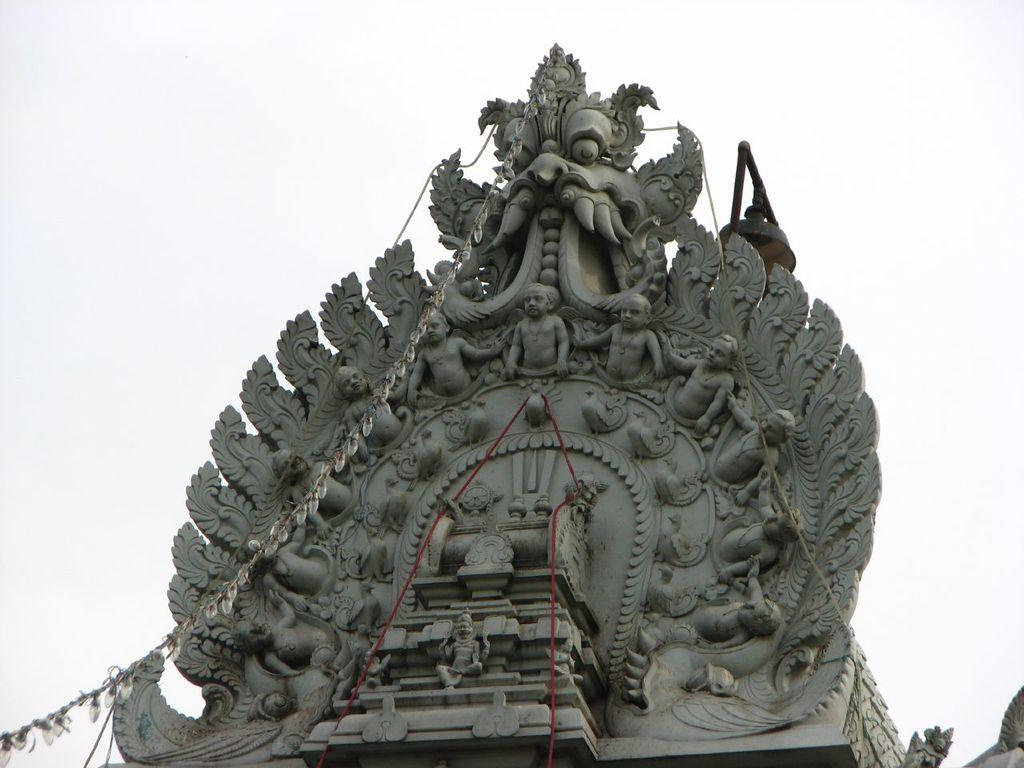What is the main subject in the image? There is a statue in the image. What color is the background of the image? The background of the image is white in color. Is there any soap visible in the image? There is no soap present in the image. Is the statue resting in the image? The statue is not resting or performing any action in the image, as it is a stationary object. 